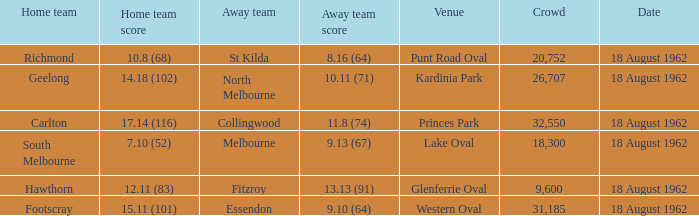11 (83) was the number of attendees higher than 31,185? None. Could you parse the entire table as a dict? {'header': ['Home team', 'Home team score', 'Away team', 'Away team score', 'Venue', 'Crowd', 'Date'], 'rows': [['Richmond', '10.8 (68)', 'St Kilda', '8.16 (64)', 'Punt Road Oval', '20,752', '18 August 1962'], ['Geelong', '14.18 (102)', 'North Melbourne', '10.11 (71)', 'Kardinia Park', '26,707', '18 August 1962'], ['Carlton', '17.14 (116)', 'Collingwood', '11.8 (74)', 'Princes Park', '32,550', '18 August 1962'], ['South Melbourne', '7.10 (52)', 'Melbourne', '9.13 (67)', 'Lake Oval', '18,300', '18 August 1962'], ['Hawthorn', '12.11 (83)', 'Fitzroy', '13.13 (91)', 'Glenferrie Oval', '9,600', '18 August 1962'], ['Footscray', '15.11 (101)', 'Essendon', '9.10 (64)', 'Western Oval', '31,185', '18 August 1962']]} 